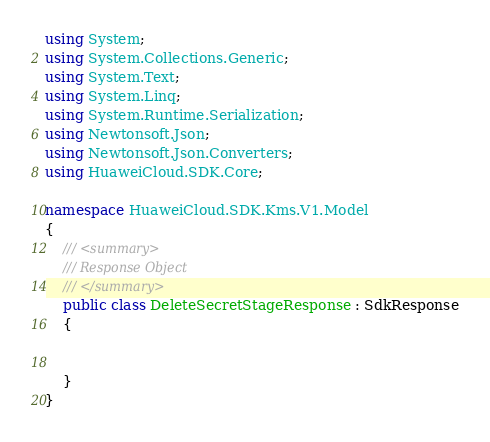<code> <loc_0><loc_0><loc_500><loc_500><_C#_>using System;
using System.Collections.Generic;
using System.Text;
using System.Linq;
using System.Runtime.Serialization;
using Newtonsoft.Json;
using Newtonsoft.Json.Converters;
using HuaweiCloud.SDK.Core;

namespace HuaweiCloud.SDK.Kms.V1.Model
{
    /// <summary>
    /// Response Object
    /// </summary>
    public class DeleteSecretStageResponse : SdkResponse
    {


    }
}
</code> 